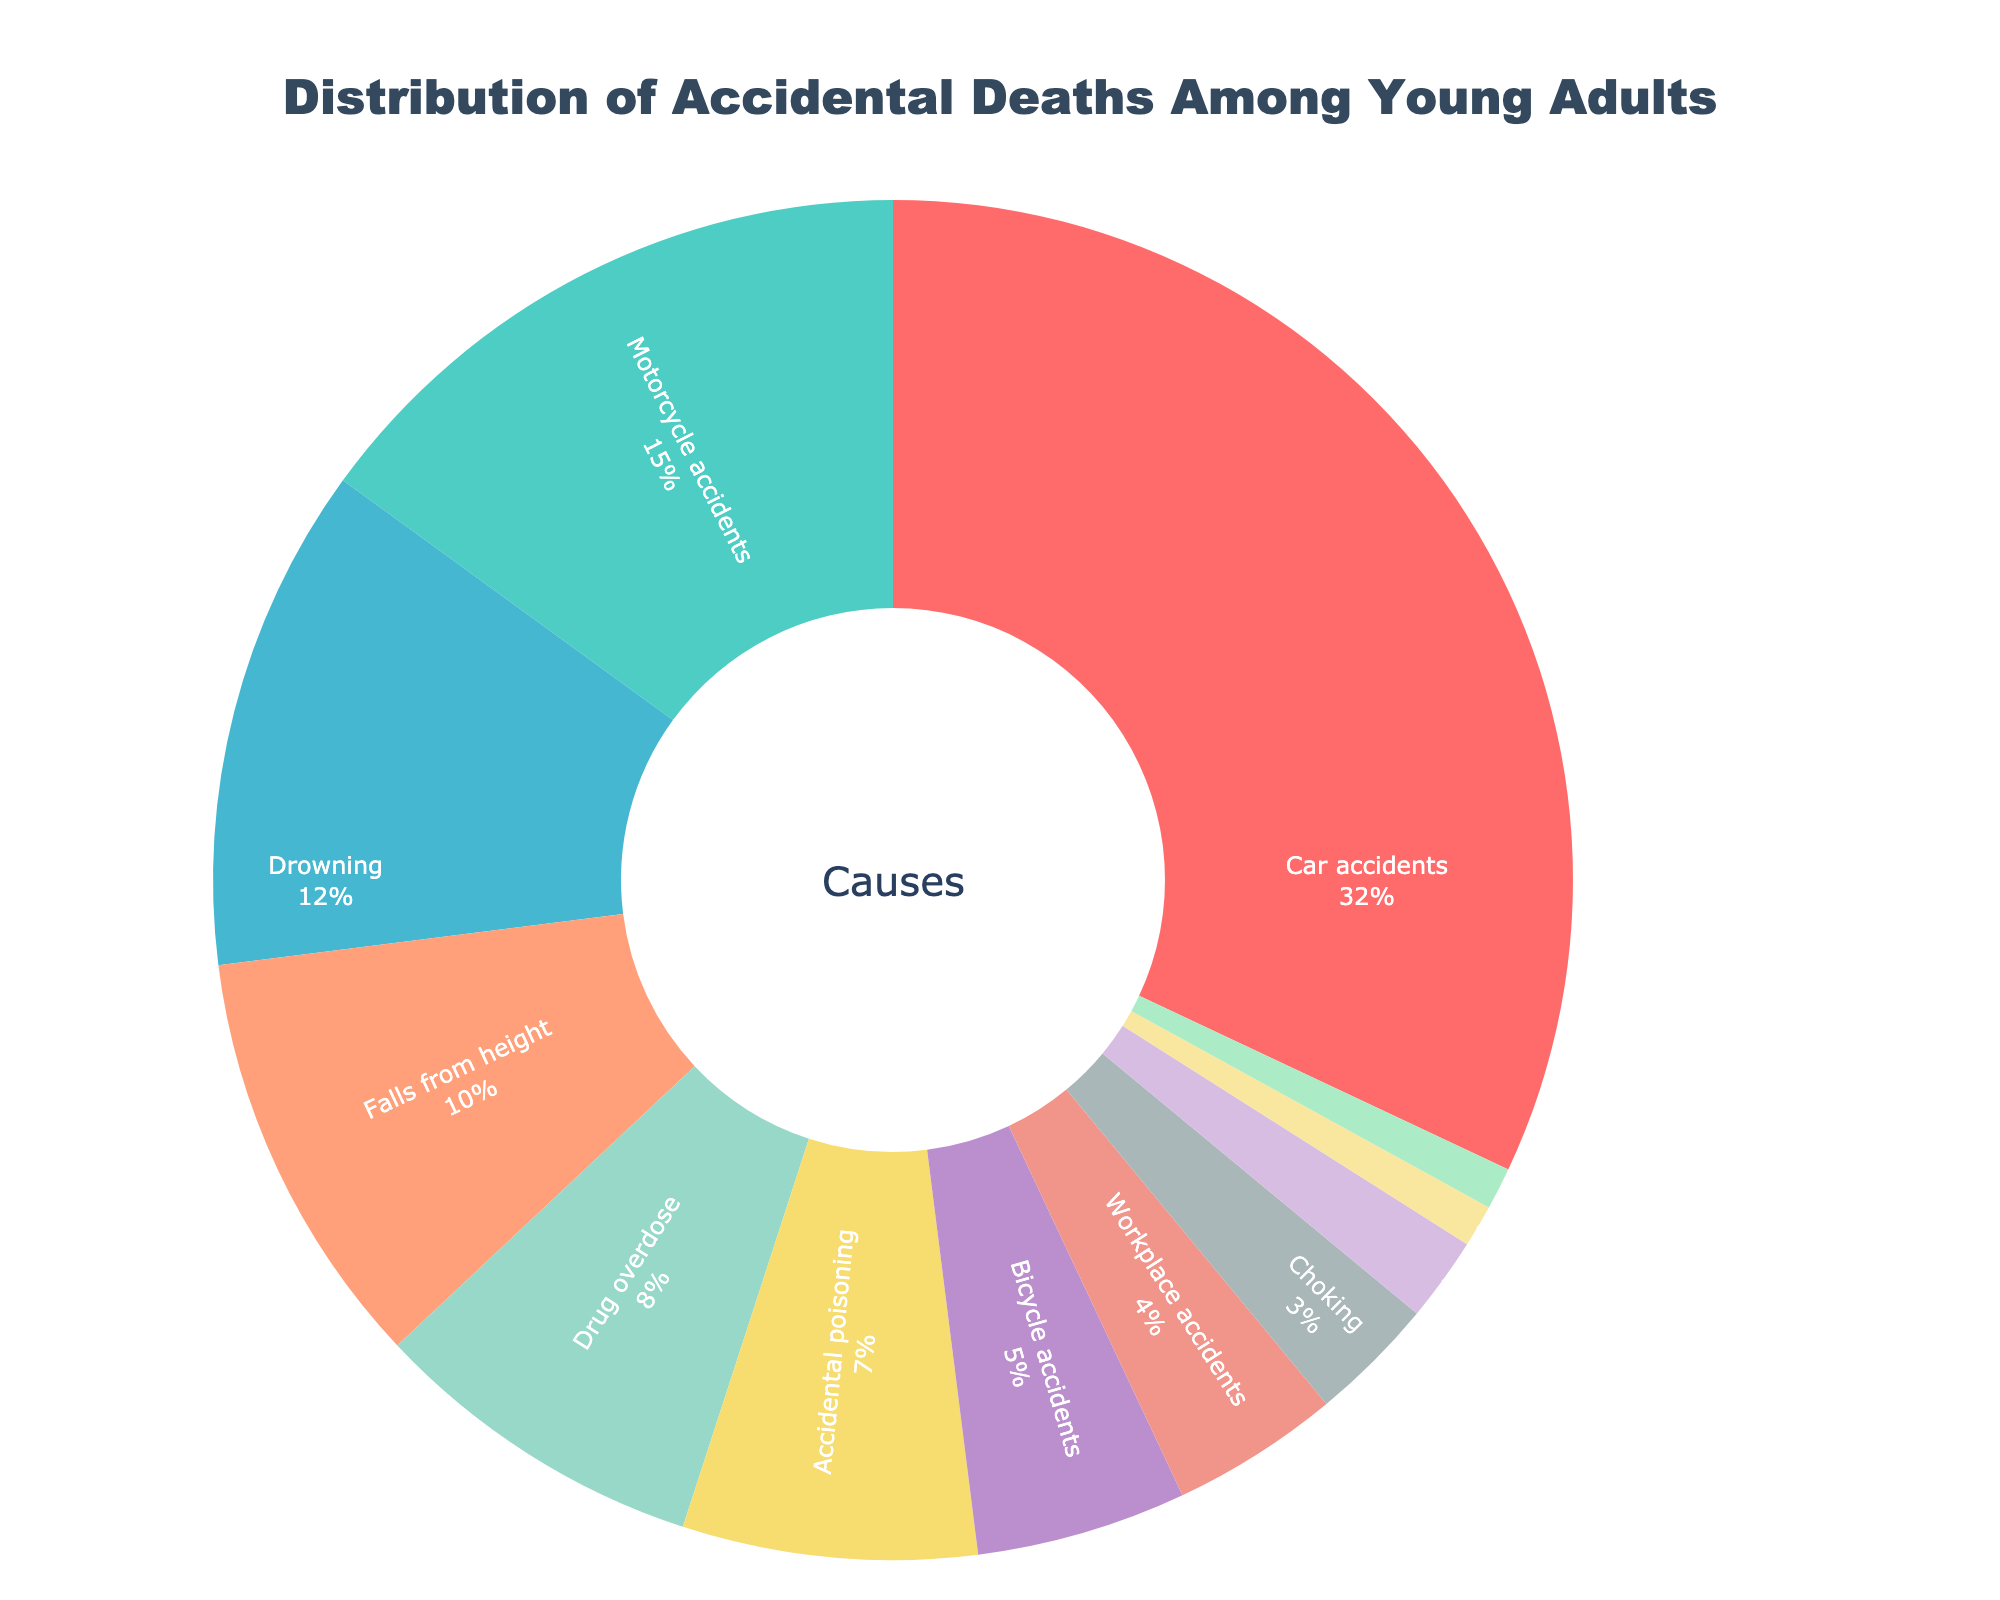What is the percentage of deaths due to vehicle-related accidents (car, motorcycle, and bicycle accidents combined)? Add the percentages of car accidents (32%), motorcycle accidents (15%), and bicycle accidents (5%): 32 + 15 + 5 = 52%.
Answer: 52% Which cause of accidental death is the highest? The cause with the highest percentage, which is highlighted in the figure, is car accidents at 32%.
Answer: Car accidents How much higher is the percentage of car accidents compared to drowning? Subtract the percentage of drowning (12%) from the percentage of car accidents (32%): 32 - 12 = 20%.
Answer: 20% What percentage of deaths is due to falls from height? The figure shows that falls from height account for 10% of accidental deaths.
Answer: 10% Among the listed causes, which one has the smallest percentage? The cause with the smallest percentage visible in the chart is pedestrian accidents at 1%.
Answer: Pedestrian accidents Are drowning-related deaths higher than drug overdose deaths? Compare the percentages: drowning is 12%, while drug overdose is 8%. Since 12% is greater than 8%, drowning-related deaths are higher.
Answer: Yes What is the combined percentage of deaths from drug overdose and accidental poisoning? Add the percentages of drug overdose (8%) and accidental poisoning (7%): 8 + 7 = 15%.
Answer: 15% If the deaths from choking, fire-related incidents, and sports-related accidents are combined, what is their total percentage? Add the percentages of choking (3%), fire-related incidents (2%), and sports-related accidents (1%): 3 + 2 + 1 = 6%.
Answer: 6% How do workplace accidents compare with bicycle accidents in terms of percentage? Workplace accidents are 4%, and bicycle accidents are 5%. Since 4% is less than 5%, workplace accidents are less common.
Answer: Workplace accidents are less common than bicycle accidents 